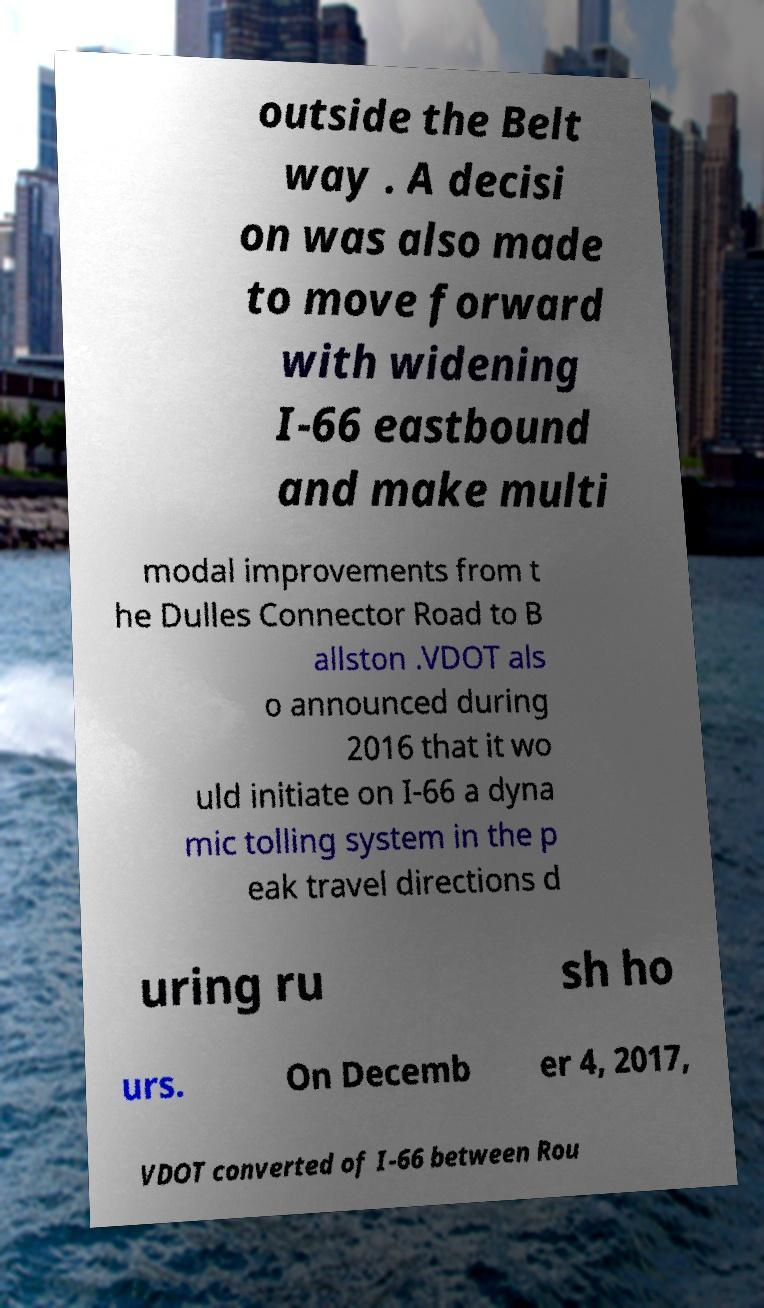I need the written content from this picture converted into text. Can you do that? outside the Belt way . A decisi on was also made to move forward with widening I-66 eastbound and make multi modal improvements from t he Dulles Connector Road to B allston .VDOT als o announced during 2016 that it wo uld initiate on I-66 a dyna mic tolling system in the p eak travel directions d uring ru sh ho urs. On Decemb er 4, 2017, VDOT converted of I-66 between Rou 